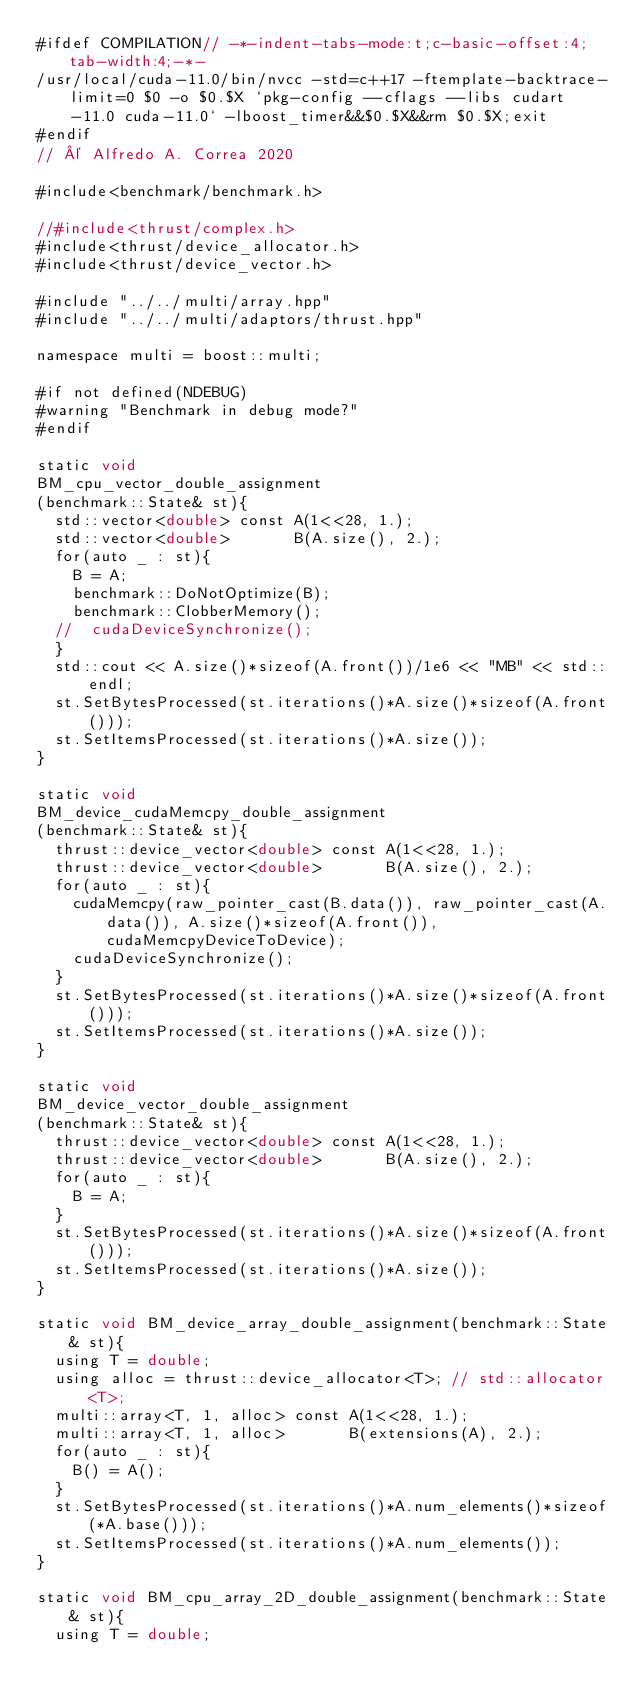<code> <loc_0><loc_0><loc_500><loc_500><_Cuda_>#ifdef COMPILATION// -*-indent-tabs-mode:t;c-basic-offset:4;tab-width:4;-*-
/usr/local/cuda-11.0/bin/nvcc -std=c++17 -ftemplate-backtrace-limit=0 $0 -o $0.$X `pkg-config --cflags --libs cudart-11.0 cuda-11.0` -lboost_timer&&$0.$X&&rm $0.$X;exit
#endif
// © Alfredo A. Correa 2020

#include<benchmark/benchmark.h>

//#include<thrust/complex.h>
#include<thrust/device_allocator.h>
#include<thrust/device_vector.h>

#include "../../multi/array.hpp"
#include "../../multi/adaptors/thrust.hpp"

namespace multi = boost::multi;

#if not defined(NDEBUG)
#warning "Benchmark in debug mode?"
#endif

static void 
BM_cpu_vector_double_assignment
(benchmark::State& st){
	std::vector<double> const A(1<<28, 1.);
	std::vector<double>       B(A.size(), 2.);
	for(auto _ : st){
		B = A;
		benchmark::DoNotOptimize(B);
		benchmark::ClobberMemory();
	//	cudaDeviceSynchronize();
	}
	std::cout << A.size()*sizeof(A.front())/1e6 << "MB" << std::endl;
	st.SetBytesProcessed(st.iterations()*A.size()*sizeof(A.front()));
	st.SetItemsProcessed(st.iterations()*A.size());
}

static void 
BM_device_cudaMemcpy_double_assignment
(benchmark::State& st){
	thrust::device_vector<double> const A(1<<28, 1.);
	thrust::device_vector<double>       B(A.size(), 2.);
	for(auto _ : st){
		cudaMemcpy(raw_pointer_cast(B.data()), raw_pointer_cast(A.data()), A.size()*sizeof(A.front()), cudaMemcpyDeviceToDevice);
		cudaDeviceSynchronize();
	}
	st.SetBytesProcessed(st.iterations()*A.size()*sizeof(A.front()));
	st.SetItemsProcessed(st.iterations()*A.size());
}

static void 
BM_device_vector_double_assignment
(benchmark::State& st){
	thrust::device_vector<double> const A(1<<28, 1.);
	thrust::device_vector<double>       B(A.size(), 2.);
	for(auto _ : st){
		B = A;
	}
	st.SetBytesProcessed(st.iterations()*A.size()*sizeof(A.front()));
	st.SetItemsProcessed(st.iterations()*A.size());
}

static void BM_device_array_double_assignment(benchmark::State& st){
	using T = double;
	using alloc = thrust::device_allocator<T>; // std::allocator<T>;
	multi::array<T, 1, alloc> const A(1<<28, 1.);
	multi::array<T, 1, alloc>       B(extensions(A), 2.);
	for(auto _ : st){
		B() = A();
	}
	st.SetBytesProcessed(st.iterations()*A.num_elements()*sizeof(*A.base()));
	st.SetItemsProcessed(st.iterations()*A.num_elements());
}

static void BM_cpu_array_2D_double_assignment(benchmark::State& st){
	using T = double;</code> 